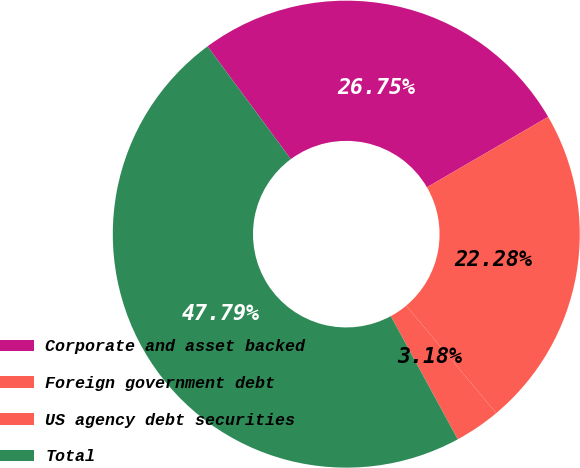<chart> <loc_0><loc_0><loc_500><loc_500><pie_chart><fcel>Corporate and asset backed<fcel>Foreign government debt<fcel>US agency debt securities<fcel>Total<nl><fcel>26.75%<fcel>22.28%<fcel>3.18%<fcel>47.79%<nl></chart> 